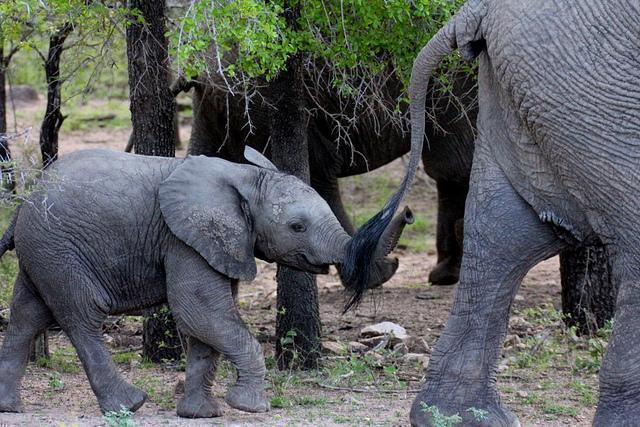Whos is the little elephant likely following?
Make your selection from the four choices given to correctly answer the question.
Options: Friend, teacher, mother, great grandfather. Mother. 